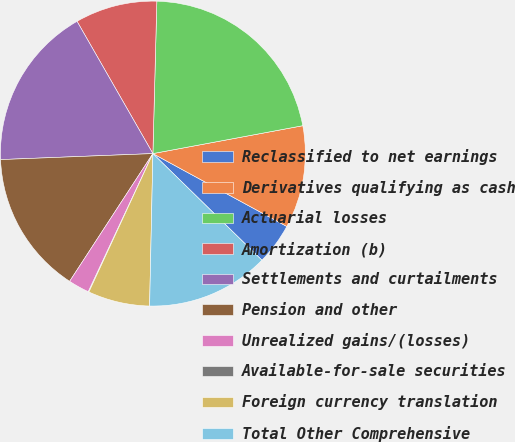Convert chart. <chart><loc_0><loc_0><loc_500><loc_500><pie_chart><fcel>Reclassified to net earnings<fcel>Derivatives qualifying as cash<fcel>Actuarial losses<fcel>Amortization (b)<fcel>Settlements and curtailments<fcel>Pension and other<fcel>Unrealized gains/(losses)<fcel>Available-for-sale securities<fcel>Foreign currency translation<fcel>Total Other Comprehensive<nl><fcel>4.39%<fcel>10.86%<fcel>21.66%<fcel>8.7%<fcel>17.34%<fcel>15.18%<fcel>2.23%<fcel>0.07%<fcel>6.55%<fcel>13.02%<nl></chart> 